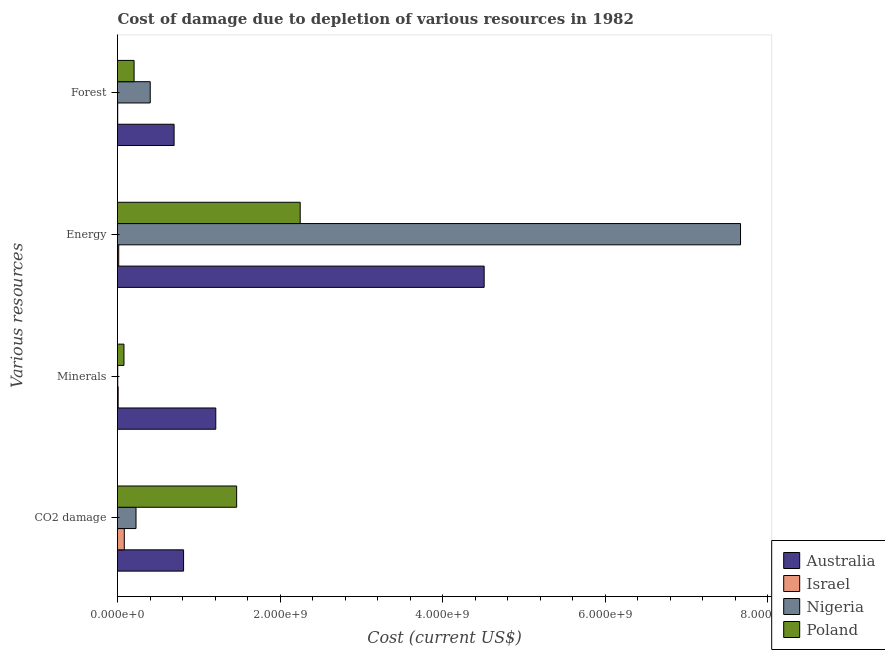How many groups of bars are there?
Your answer should be compact. 4. Are the number of bars per tick equal to the number of legend labels?
Ensure brevity in your answer.  Yes. How many bars are there on the 3rd tick from the top?
Ensure brevity in your answer.  4. How many bars are there on the 3rd tick from the bottom?
Provide a short and direct response. 4. What is the label of the 2nd group of bars from the top?
Make the answer very short. Energy. What is the cost of damage due to depletion of forests in Australia?
Ensure brevity in your answer.  6.96e+08. Across all countries, what is the maximum cost of damage due to depletion of energy?
Your answer should be very brief. 7.67e+09. Across all countries, what is the minimum cost of damage due to depletion of energy?
Your answer should be compact. 1.50e+07. In which country was the cost of damage due to depletion of energy maximum?
Keep it short and to the point. Nigeria. In which country was the cost of damage due to depletion of minerals minimum?
Your response must be concise. Nigeria. What is the total cost of damage due to depletion of forests in the graph?
Your answer should be compact. 1.31e+09. What is the difference between the cost of damage due to depletion of minerals in Israel and that in Australia?
Your answer should be very brief. -1.20e+09. What is the difference between the cost of damage due to depletion of forests in Israel and the cost of damage due to depletion of minerals in Australia?
Your response must be concise. -1.21e+09. What is the average cost of damage due to depletion of forests per country?
Your answer should be very brief. 3.26e+08. What is the difference between the cost of damage due to depletion of energy and cost of damage due to depletion of forests in Nigeria?
Offer a very short reply. 7.26e+09. What is the ratio of the cost of damage due to depletion of energy in Israel to that in Nigeria?
Provide a short and direct response. 0. Is the cost of damage due to depletion of minerals in Australia less than that in Nigeria?
Your response must be concise. No. Is the difference between the cost of damage due to depletion of coal in Australia and Nigeria greater than the difference between the cost of damage due to depletion of energy in Australia and Nigeria?
Make the answer very short. Yes. What is the difference between the highest and the second highest cost of damage due to depletion of energy?
Ensure brevity in your answer.  3.16e+09. What is the difference between the highest and the lowest cost of damage due to depletion of forests?
Ensure brevity in your answer.  6.94e+08. What does the 3rd bar from the top in Minerals represents?
Keep it short and to the point. Israel. Is it the case that in every country, the sum of the cost of damage due to depletion of coal and cost of damage due to depletion of minerals is greater than the cost of damage due to depletion of energy?
Ensure brevity in your answer.  No. How many bars are there?
Your response must be concise. 16. Are all the bars in the graph horizontal?
Offer a very short reply. Yes. Does the graph contain any zero values?
Provide a succinct answer. No. Where does the legend appear in the graph?
Your answer should be compact. Bottom right. How are the legend labels stacked?
Provide a short and direct response. Vertical. What is the title of the graph?
Keep it short and to the point. Cost of damage due to depletion of various resources in 1982 . Does "El Salvador" appear as one of the legend labels in the graph?
Provide a short and direct response. No. What is the label or title of the X-axis?
Provide a succinct answer. Cost (current US$). What is the label or title of the Y-axis?
Offer a terse response. Various resources. What is the Cost (current US$) of Australia in CO2 damage?
Offer a very short reply. 8.13e+08. What is the Cost (current US$) of Israel in CO2 damage?
Your answer should be compact. 8.36e+07. What is the Cost (current US$) in Nigeria in CO2 damage?
Provide a succinct answer. 2.28e+08. What is the Cost (current US$) in Poland in CO2 damage?
Offer a terse response. 1.47e+09. What is the Cost (current US$) in Australia in Minerals?
Make the answer very short. 1.21e+09. What is the Cost (current US$) of Israel in Minerals?
Your answer should be compact. 8.15e+06. What is the Cost (current US$) of Nigeria in Minerals?
Provide a short and direct response. 3.01e+06. What is the Cost (current US$) of Poland in Minerals?
Offer a very short reply. 7.95e+07. What is the Cost (current US$) in Australia in Energy?
Make the answer very short. 4.51e+09. What is the Cost (current US$) of Israel in Energy?
Ensure brevity in your answer.  1.50e+07. What is the Cost (current US$) in Nigeria in Energy?
Offer a terse response. 7.67e+09. What is the Cost (current US$) in Poland in Energy?
Your response must be concise. 2.25e+09. What is the Cost (current US$) of Australia in Forest?
Offer a terse response. 6.96e+08. What is the Cost (current US$) of Israel in Forest?
Provide a succinct answer. 2.43e+06. What is the Cost (current US$) in Nigeria in Forest?
Make the answer very short. 4.03e+08. What is the Cost (current US$) in Poland in Forest?
Provide a succinct answer. 2.04e+08. Across all Various resources, what is the maximum Cost (current US$) of Australia?
Your response must be concise. 4.51e+09. Across all Various resources, what is the maximum Cost (current US$) of Israel?
Provide a succinct answer. 8.36e+07. Across all Various resources, what is the maximum Cost (current US$) in Nigeria?
Ensure brevity in your answer.  7.67e+09. Across all Various resources, what is the maximum Cost (current US$) in Poland?
Your answer should be very brief. 2.25e+09. Across all Various resources, what is the minimum Cost (current US$) of Australia?
Your response must be concise. 6.96e+08. Across all Various resources, what is the minimum Cost (current US$) in Israel?
Keep it short and to the point. 2.43e+06. Across all Various resources, what is the minimum Cost (current US$) of Nigeria?
Provide a short and direct response. 3.01e+06. Across all Various resources, what is the minimum Cost (current US$) in Poland?
Offer a terse response. 7.95e+07. What is the total Cost (current US$) of Australia in the graph?
Ensure brevity in your answer.  7.23e+09. What is the total Cost (current US$) in Israel in the graph?
Your answer should be very brief. 1.09e+08. What is the total Cost (current US$) of Nigeria in the graph?
Make the answer very short. 8.30e+09. What is the total Cost (current US$) in Poland in the graph?
Give a very brief answer. 4.00e+09. What is the difference between the Cost (current US$) in Australia in CO2 damage and that in Minerals?
Your answer should be very brief. -3.96e+08. What is the difference between the Cost (current US$) of Israel in CO2 damage and that in Minerals?
Keep it short and to the point. 7.55e+07. What is the difference between the Cost (current US$) in Nigeria in CO2 damage and that in Minerals?
Your answer should be compact. 2.25e+08. What is the difference between the Cost (current US$) of Poland in CO2 damage and that in Minerals?
Ensure brevity in your answer.  1.39e+09. What is the difference between the Cost (current US$) in Australia in CO2 damage and that in Energy?
Provide a succinct answer. -3.70e+09. What is the difference between the Cost (current US$) of Israel in CO2 damage and that in Energy?
Your answer should be compact. 6.86e+07. What is the difference between the Cost (current US$) in Nigeria in CO2 damage and that in Energy?
Your answer should be compact. -7.44e+09. What is the difference between the Cost (current US$) in Poland in CO2 damage and that in Energy?
Keep it short and to the point. -7.82e+08. What is the difference between the Cost (current US$) in Australia in CO2 damage and that in Forest?
Make the answer very short. 1.17e+08. What is the difference between the Cost (current US$) of Israel in CO2 damage and that in Forest?
Your answer should be compact. 8.12e+07. What is the difference between the Cost (current US$) of Nigeria in CO2 damage and that in Forest?
Keep it short and to the point. -1.75e+08. What is the difference between the Cost (current US$) in Poland in CO2 damage and that in Forest?
Keep it short and to the point. 1.26e+09. What is the difference between the Cost (current US$) of Australia in Minerals and that in Energy?
Provide a succinct answer. -3.30e+09. What is the difference between the Cost (current US$) of Israel in Minerals and that in Energy?
Your response must be concise. -6.87e+06. What is the difference between the Cost (current US$) in Nigeria in Minerals and that in Energy?
Your answer should be very brief. -7.66e+09. What is the difference between the Cost (current US$) of Poland in Minerals and that in Energy?
Give a very brief answer. -2.17e+09. What is the difference between the Cost (current US$) of Australia in Minerals and that in Forest?
Your answer should be compact. 5.13e+08. What is the difference between the Cost (current US$) of Israel in Minerals and that in Forest?
Provide a succinct answer. 5.71e+06. What is the difference between the Cost (current US$) of Nigeria in Minerals and that in Forest?
Keep it short and to the point. -4.00e+08. What is the difference between the Cost (current US$) in Poland in Minerals and that in Forest?
Offer a terse response. -1.25e+08. What is the difference between the Cost (current US$) of Australia in Energy and that in Forest?
Offer a very short reply. 3.82e+09. What is the difference between the Cost (current US$) of Israel in Energy and that in Forest?
Your response must be concise. 1.26e+07. What is the difference between the Cost (current US$) of Nigeria in Energy and that in Forest?
Give a very brief answer. 7.26e+09. What is the difference between the Cost (current US$) in Poland in Energy and that in Forest?
Give a very brief answer. 2.04e+09. What is the difference between the Cost (current US$) of Australia in CO2 damage and the Cost (current US$) of Israel in Minerals?
Keep it short and to the point. 8.05e+08. What is the difference between the Cost (current US$) in Australia in CO2 damage and the Cost (current US$) in Nigeria in Minerals?
Provide a short and direct response. 8.10e+08. What is the difference between the Cost (current US$) of Australia in CO2 damage and the Cost (current US$) of Poland in Minerals?
Provide a succinct answer. 7.34e+08. What is the difference between the Cost (current US$) in Israel in CO2 damage and the Cost (current US$) in Nigeria in Minerals?
Provide a short and direct response. 8.06e+07. What is the difference between the Cost (current US$) in Israel in CO2 damage and the Cost (current US$) in Poland in Minerals?
Give a very brief answer. 4.16e+06. What is the difference between the Cost (current US$) in Nigeria in CO2 damage and the Cost (current US$) in Poland in Minerals?
Provide a succinct answer. 1.48e+08. What is the difference between the Cost (current US$) of Australia in CO2 damage and the Cost (current US$) of Israel in Energy?
Provide a succinct answer. 7.98e+08. What is the difference between the Cost (current US$) in Australia in CO2 damage and the Cost (current US$) in Nigeria in Energy?
Provide a succinct answer. -6.85e+09. What is the difference between the Cost (current US$) of Australia in CO2 damage and the Cost (current US$) of Poland in Energy?
Keep it short and to the point. -1.44e+09. What is the difference between the Cost (current US$) in Israel in CO2 damage and the Cost (current US$) in Nigeria in Energy?
Provide a succinct answer. -7.58e+09. What is the difference between the Cost (current US$) of Israel in CO2 damage and the Cost (current US$) of Poland in Energy?
Make the answer very short. -2.16e+09. What is the difference between the Cost (current US$) in Nigeria in CO2 damage and the Cost (current US$) in Poland in Energy?
Offer a very short reply. -2.02e+09. What is the difference between the Cost (current US$) of Australia in CO2 damage and the Cost (current US$) of Israel in Forest?
Your answer should be very brief. 8.11e+08. What is the difference between the Cost (current US$) of Australia in CO2 damage and the Cost (current US$) of Nigeria in Forest?
Offer a very short reply. 4.10e+08. What is the difference between the Cost (current US$) in Australia in CO2 damage and the Cost (current US$) in Poland in Forest?
Offer a terse response. 6.09e+08. What is the difference between the Cost (current US$) in Israel in CO2 damage and the Cost (current US$) in Nigeria in Forest?
Give a very brief answer. -3.19e+08. What is the difference between the Cost (current US$) of Israel in CO2 damage and the Cost (current US$) of Poland in Forest?
Ensure brevity in your answer.  -1.20e+08. What is the difference between the Cost (current US$) in Nigeria in CO2 damage and the Cost (current US$) in Poland in Forest?
Provide a short and direct response. 2.38e+07. What is the difference between the Cost (current US$) of Australia in Minerals and the Cost (current US$) of Israel in Energy?
Offer a very short reply. 1.19e+09. What is the difference between the Cost (current US$) of Australia in Minerals and the Cost (current US$) of Nigeria in Energy?
Your answer should be compact. -6.46e+09. What is the difference between the Cost (current US$) in Australia in Minerals and the Cost (current US$) in Poland in Energy?
Give a very brief answer. -1.04e+09. What is the difference between the Cost (current US$) in Israel in Minerals and the Cost (current US$) in Nigeria in Energy?
Keep it short and to the point. -7.66e+09. What is the difference between the Cost (current US$) of Israel in Minerals and the Cost (current US$) of Poland in Energy?
Provide a succinct answer. -2.24e+09. What is the difference between the Cost (current US$) of Nigeria in Minerals and the Cost (current US$) of Poland in Energy?
Keep it short and to the point. -2.25e+09. What is the difference between the Cost (current US$) in Australia in Minerals and the Cost (current US$) in Israel in Forest?
Your response must be concise. 1.21e+09. What is the difference between the Cost (current US$) in Australia in Minerals and the Cost (current US$) in Nigeria in Forest?
Keep it short and to the point. 8.07e+08. What is the difference between the Cost (current US$) in Australia in Minerals and the Cost (current US$) in Poland in Forest?
Offer a terse response. 1.01e+09. What is the difference between the Cost (current US$) of Israel in Minerals and the Cost (current US$) of Nigeria in Forest?
Ensure brevity in your answer.  -3.95e+08. What is the difference between the Cost (current US$) of Israel in Minerals and the Cost (current US$) of Poland in Forest?
Offer a terse response. -1.96e+08. What is the difference between the Cost (current US$) of Nigeria in Minerals and the Cost (current US$) of Poland in Forest?
Make the answer very short. -2.01e+08. What is the difference between the Cost (current US$) in Australia in Energy and the Cost (current US$) in Israel in Forest?
Your response must be concise. 4.51e+09. What is the difference between the Cost (current US$) of Australia in Energy and the Cost (current US$) of Nigeria in Forest?
Ensure brevity in your answer.  4.11e+09. What is the difference between the Cost (current US$) of Australia in Energy and the Cost (current US$) of Poland in Forest?
Your answer should be very brief. 4.31e+09. What is the difference between the Cost (current US$) in Israel in Energy and the Cost (current US$) in Nigeria in Forest?
Keep it short and to the point. -3.88e+08. What is the difference between the Cost (current US$) of Israel in Energy and the Cost (current US$) of Poland in Forest?
Your answer should be very brief. -1.89e+08. What is the difference between the Cost (current US$) in Nigeria in Energy and the Cost (current US$) in Poland in Forest?
Give a very brief answer. 7.46e+09. What is the average Cost (current US$) in Australia per Various resources?
Give a very brief answer. 1.81e+09. What is the average Cost (current US$) in Israel per Various resources?
Your answer should be compact. 2.73e+07. What is the average Cost (current US$) in Nigeria per Various resources?
Your response must be concise. 2.08e+09. What is the average Cost (current US$) in Poland per Various resources?
Keep it short and to the point. 1.00e+09. What is the difference between the Cost (current US$) in Australia and Cost (current US$) in Israel in CO2 damage?
Your answer should be very brief. 7.29e+08. What is the difference between the Cost (current US$) of Australia and Cost (current US$) of Nigeria in CO2 damage?
Offer a terse response. 5.85e+08. What is the difference between the Cost (current US$) in Australia and Cost (current US$) in Poland in CO2 damage?
Your answer should be compact. -6.53e+08. What is the difference between the Cost (current US$) of Israel and Cost (current US$) of Nigeria in CO2 damage?
Your answer should be very brief. -1.44e+08. What is the difference between the Cost (current US$) of Israel and Cost (current US$) of Poland in CO2 damage?
Keep it short and to the point. -1.38e+09. What is the difference between the Cost (current US$) of Nigeria and Cost (current US$) of Poland in CO2 damage?
Offer a very short reply. -1.24e+09. What is the difference between the Cost (current US$) in Australia and Cost (current US$) in Israel in Minerals?
Your response must be concise. 1.20e+09. What is the difference between the Cost (current US$) in Australia and Cost (current US$) in Nigeria in Minerals?
Your answer should be very brief. 1.21e+09. What is the difference between the Cost (current US$) in Australia and Cost (current US$) in Poland in Minerals?
Provide a short and direct response. 1.13e+09. What is the difference between the Cost (current US$) in Israel and Cost (current US$) in Nigeria in Minerals?
Your response must be concise. 5.14e+06. What is the difference between the Cost (current US$) of Israel and Cost (current US$) of Poland in Minerals?
Give a very brief answer. -7.13e+07. What is the difference between the Cost (current US$) of Nigeria and Cost (current US$) of Poland in Minerals?
Give a very brief answer. -7.65e+07. What is the difference between the Cost (current US$) in Australia and Cost (current US$) in Israel in Energy?
Give a very brief answer. 4.50e+09. What is the difference between the Cost (current US$) of Australia and Cost (current US$) of Nigeria in Energy?
Your answer should be very brief. -3.16e+09. What is the difference between the Cost (current US$) in Australia and Cost (current US$) in Poland in Energy?
Your answer should be very brief. 2.26e+09. What is the difference between the Cost (current US$) in Israel and Cost (current US$) in Nigeria in Energy?
Offer a terse response. -7.65e+09. What is the difference between the Cost (current US$) of Israel and Cost (current US$) of Poland in Energy?
Give a very brief answer. -2.23e+09. What is the difference between the Cost (current US$) of Nigeria and Cost (current US$) of Poland in Energy?
Your answer should be very brief. 5.42e+09. What is the difference between the Cost (current US$) of Australia and Cost (current US$) of Israel in Forest?
Offer a very short reply. 6.94e+08. What is the difference between the Cost (current US$) in Australia and Cost (current US$) in Nigeria in Forest?
Make the answer very short. 2.94e+08. What is the difference between the Cost (current US$) of Australia and Cost (current US$) of Poland in Forest?
Provide a short and direct response. 4.92e+08. What is the difference between the Cost (current US$) in Israel and Cost (current US$) in Nigeria in Forest?
Give a very brief answer. -4.00e+08. What is the difference between the Cost (current US$) in Israel and Cost (current US$) in Poland in Forest?
Your response must be concise. -2.02e+08. What is the difference between the Cost (current US$) in Nigeria and Cost (current US$) in Poland in Forest?
Your answer should be compact. 1.99e+08. What is the ratio of the Cost (current US$) of Australia in CO2 damage to that in Minerals?
Provide a succinct answer. 0.67. What is the ratio of the Cost (current US$) of Israel in CO2 damage to that in Minerals?
Provide a short and direct response. 10.27. What is the ratio of the Cost (current US$) in Nigeria in CO2 damage to that in Minerals?
Your response must be concise. 75.73. What is the ratio of the Cost (current US$) of Poland in CO2 damage to that in Minerals?
Offer a terse response. 18.45. What is the ratio of the Cost (current US$) of Australia in CO2 damage to that in Energy?
Make the answer very short. 0.18. What is the ratio of the Cost (current US$) in Israel in CO2 damage to that in Energy?
Give a very brief answer. 5.57. What is the ratio of the Cost (current US$) in Nigeria in CO2 damage to that in Energy?
Make the answer very short. 0.03. What is the ratio of the Cost (current US$) in Poland in CO2 damage to that in Energy?
Offer a very short reply. 0.65. What is the ratio of the Cost (current US$) in Australia in CO2 damage to that in Forest?
Provide a succinct answer. 1.17. What is the ratio of the Cost (current US$) in Israel in CO2 damage to that in Forest?
Give a very brief answer. 34.37. What is the ratio of the Cost (current US$) of Nigeria in CO2 damage to that in Forest?
Your response must be concise. 0.57. What is the ratio of the Cost (current US$) of Poland in CO2 damage to that in Forest?
Your answer should be very brief. 7.19. What is the ratio of the Cost (current US$) in Australia in Minerals to that in Energy?
Offer a terse response. 0.27. What is the ratio of the Cost (current US$) in Israel in Minerals to that in Energy?
Provide a short and direct response. 0.54. What is the ratio of the Cost (current US$) of Poland in Minerals to that in Energy?
Keep it short and to the point. 0.04. What is the ratio of the Cost (current US$) of Australia in Minerals to that in Forest?
Keep it short and to the point. 1.74. What is the ratio of the Cost (current US$) of Israel in Minerals to that in Forest?
Offer a very short reply. 3.35. What is the ratio of the Cost (current US$) of Nigeria in Minerals to that in Forest?
Keep it short and to the point. 0.01. What is the ratio of the Cost (current US$) of Poland in Minerals to that in Forest?
Provide a short and direct response. 0.39. What is the ratio of the Cost (current US$) in Australia in Energy to that in Forest?
Offer a terse response. 6.48. What is the ratio of the Cost (current US$) in Israel in Energy to that in Forest?
Provide a succinct answer. 6.17. What is the ratio of the Cost (current US$) in Nigeria in Energy to that in Forest?
Offer a terse response. 19.04. What is the ratio of the Cost (current US$) of Poland in Energy to that in Forest?
Your answer should be very brief. 11.02. What is the difference between the highest and the second highest Cost (current US$) of Australia?
Your answer should be compact. 3.30e+09. What is the difference between the highest and the second highest Cost (current US$) of Israel?
Your answer should be very brief. 6.86e+07. What is the difference between the highest and the second highest Cost (current US$) of Nigeria?
Your response must be concise. 7.26e+09. What is the difference between the highest and the second highest Cost (current US$) in Poland?
Offer a terse response. 7.82e+08. What is the difference between the highest and the lowest Cost (current US$) of Australia?
Your answer should be compact. 3.82e+09. What is the difference between the highest and the lowest Cost (current US$) of Israel?
Provide a succinct answer. 8.12e+07. What is the difference between the highest and the lowest Cost (current US$) in Nigeria?
Make the answer very short. 7.66e+09. What is the difference between the highest and the lowest Cost (current US$) in Poland?
Give a very brief answer. 2.17e+09. 